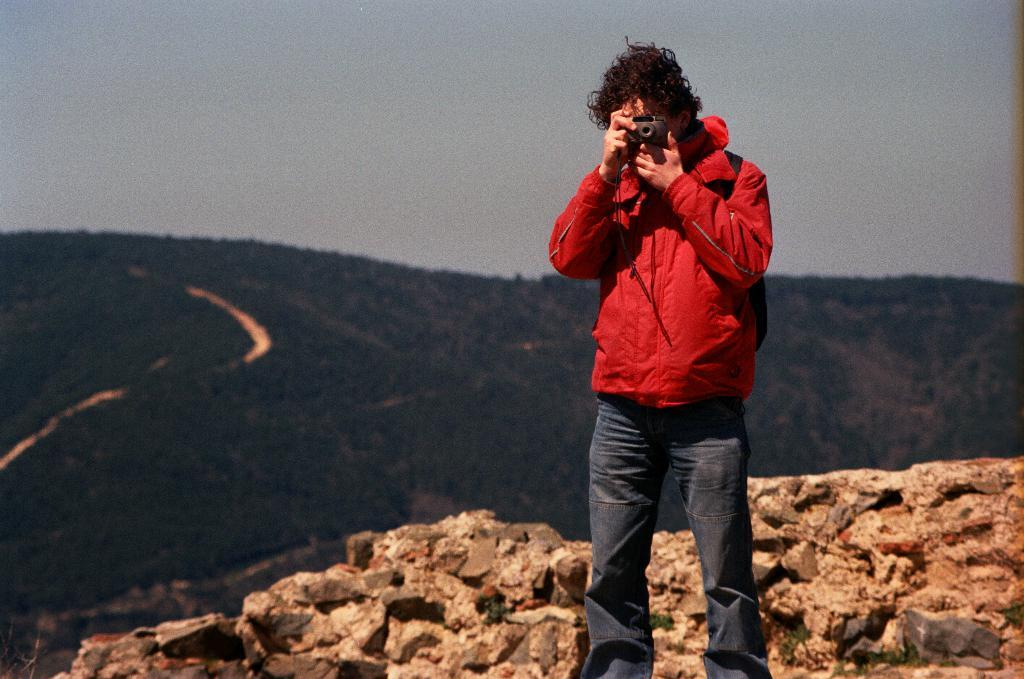What is the person in the image doing? The person is standing in the image and appears to be capturing something. What is the person holding in the image? The person is holding a camera in the image. What can be seen in the background of the image? There are mountains in the background of the image. What type of wood is the person's eyes made of in the image? The person's eyes are not made of wood in the image; they are a natural part of the person's face. 